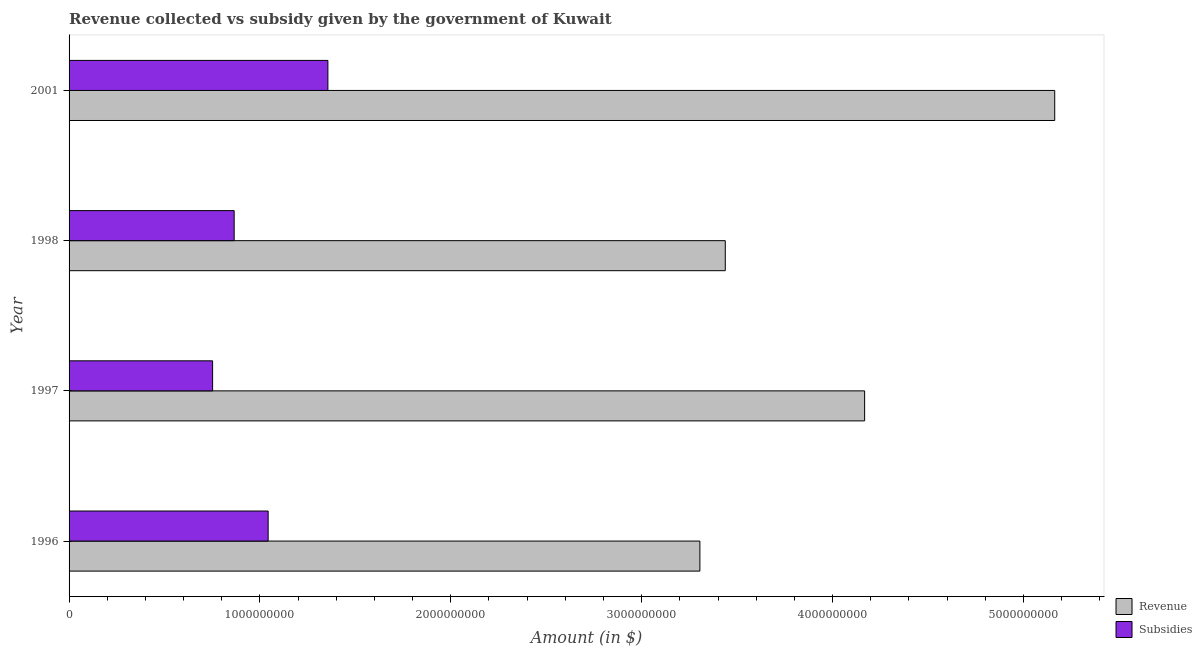How many different coloured bars are there?
Provide a succinct answer. 2. Are the number of bars on each tick of the Y-axis equal?
Give a very brief answer. Yes. How many bars are there on the 4th tick from the top?
Ensure brevity in your answer.  2. What is the label of the 2nd group of bars from the top?
Offer a very short reply. 1998. In how many cases, is the number of bars for a given year not equal to the number of legend labels?
Your response must be concise. 0. What is the amount of revenue collected in 1998?
Give a very brief answer. 3.44e+09. Across all years, what is the maximum amount of revenue collected?
Your response must be concise. 5.16e+09. Across all years, what is the minimum amount of subsidies given?
Provide a succinct answer. 7.52e+08. In which year was the amount of subsidies given minimum?
Keep it short and to the point. 1997. What is the total amount of subsidies given in the graph?
Your response must be concise. 4.02e+09. What is the difference between the amount of revenue collected in 1996 and that in 1997?
Your answer should be very brief. -8.63e+08. What is the difference between the amount of subsidies given in 1997 and the amount of revenue collected in 1996?
Offer a very short reply. -2.55e+09. What is the average amount of revenue collected per year?
Keep it short and to the point. 4.02e+09. In the year 1998, what is the difference between the amount of subsidies given and amount of revenue collected?
Provide a short and direct response. -2.57e+09. In how many years, is the amount of revenue collected greater than 4800000000 $?
Your answer should be compact. 1. What is the ratio of the amount of subsidies given in 1998 to that in 2001?
Offer a terse response. 0.64. Is the amount of revenue collected in 1996 less than that in 2001?
Offer a very short reply. Yes. Is the difference between the amount of revenue collected in 1996 and 2001 greater than the difference between the amount of subsidies given in 1996 and 2001?
Give a very brief answer. No. What is the difference between the highest and the second highest amount of revenue collected?
Your answer should be very brief. 9.96e+08. What is the difference between the highest and the lowest amount of revenue collected?
Provide a short and direct response. 1.86e+09. In how many years, is the amount of revenue collected greater than the average amount of revenue collected taken over all years?
Provide a short and direct response. 2. What does the 1st bar from the top in 2001 represents?
Offer a terse response. Subsidies. What does the 1st bar from the bottom in 1998 represents?
Offer a terse response. Revenue. How many bars are there?
Give a very brief answer. 8. What is the difference between two consecutive major ticks on the X-axis?
Keep it short and to the point. 1.00e+09. Does the graph contain grids?
Your answer should be very brief. No. How many legend labels are there?
Your answer should be very brief. 2. How are the legend labels stacked?
Provide a succinct answer. Vertical. What is the title of the graph?
Your response must be concise. Revenue collected vs subsidy given by the government of Kuwait. What is the label or title of the X-axis?
Offer a terse response. Amount (in $). What is the Amount (in $) of Revenue in 1996?
Keep it short and to the point. 3.30e+09. What is the Amount (in $) in Subsidies in 1996?
Provide a succinct answer. 1.04e+09. What is the Amount (in $) of Revenue in 1997?
Offer a terse response. 4.17e+09. What is the Amount (in $) in Subsidies in 1997?
Provide a succinct answer. 7.52e+08. What is the Amount (in $) of Revenue in 1998?
Offer a very short reply. 3.44e+09. What is the Amount (in $) of Subsidies in 1998?
Your answer should be compact. 8.65e+08. What is the Amount (in $) of Revenue in 2001?
Give a very brief answer. 5.16e+09. What is the Amount (in $) in Subsidies in 2001?
Your answer should be very brief. 1.36e+09. Across all years, what is the maximum Amount (in $) in Revenue?
Offer a very short reply. 5.16e+09. Across all years, what is the maximum Amount (in $) of Subsidies?
Offer a very short reply. 1.36e+09. Across all years, what is the minimum Amount (in $) of Revenue?
Make the answer very short. 3.30e+09. Across all years, what is the minimum Amount (in $) of Subsidies?
Keep it short and to the point. 7.52e+08. What is the total Amount (in $) in Revenue in the graph?
Offer a terse response. 1.61e+1. What is the total Amount (in $) of Subsidies in the graph?
Your response must be concise. 4.02e+09. What is the difference between the Amount (in $) of Revenue in 1996 and that in 1997?
Provide a succinct answer. -8.63e+08. What is the difference between the Amount (in $) in Subsidies in 1996 and that in 1997?
Keep it short and to the point. 2.91e+08. What is the difference between the Amount (in $) of Revenue in 1996 and that in 1998?
Ensure brevity in your answer.  -1.33e+08. What is the difference between the Amount (in $) of Subsidies in 1996 and that in 1998?
Your answer should be compact. 1.78e+08. What is the difference between the Amount (in $) in Revenue in 1996 and that in 2001?
Give a very brief answer. -1.86e+09. What is the difference between the Amount (in $) of Subsidies in 1996 and that in 2001?
Make the answer very short. -3.13e+08. What is the difference between the Amount (in $) in Revenue in 1997 and that in 1998?
Keep it short and to the point. 7.30e+08. What is the difference between the Amount (in $) of Subsidies in 1997 and that in 1998?
Provide a succinct answer. -1.13e+08. What is the difference between the Amount (in $) in Revenue in 1997 and that in 2001?
Offer a terse response. -9.96e+08. What is the difference between the Amount (in $) of Subsidies in 1997 and that in 2001?
Provide a succinct answer. -6.04e+08. What is the difference between the Amount (in $) of Revenue in 1998 and that in 2001?
Make the answer very short. -1.73e+09. What is the difference between the Amount (in $) of Subsidies in 1998 and that in 2001?
Keep it short and to the point. -4.91e+08. What is the difference between the Amount (in $) in Revenue in 1996 and the Amount (in $) in Subsidies in 1997?
Your answer should be very brief. 2.55e+09. What is the difference between the Amount (in $) in Revenue in 1996 and the Amount (in $) in Subsidies in 1998?
Your answer should be compact. 2.44e+09. What is the difference between the Amount (in $) of Revenue in 1996 and the Amount (in $) of Subsidies in 2001?
Your answer should be very brief. 1.95e+09. What is the difference between the Amount (in $) of Revenue in 1997 and the Amount (in $) of Subsidies in 1998?
Keep it short and to the point. 3.30e+09. What is the difference between the Amount (in $) of Revenue in 1997 and the Amount (in $) of Subsidies in 2001?
Your answer should be compact. 2.81e+09. What is the difference between the Amount (in $) in Revenue in 1998 and the Amount (in $) in Subsidies in 2001?
Your answer should be very brief. 2.08e+09. What is the average Amount (in $) in Revenue per year?
Your answer should be compact. 4.02e+09. What is the average Amount (in $) of Subsidies per year?
Your answer should be compact. 1.00e+09. In the year 1996, what is the difference between the Amount (in $) of Revenue and Amount (in $) of Subsidies?
Your answer should be very brief. 2.26e+09. In the year 1997, what is the difference between the Amount (in $) in Revenue and Amount (in $) in Subsidies?
Keep it short and to the point. 3.42e+09. In the year 1998, what is the difference between the Amount (in $) in Revenue and Amount (in $) in Subsidies?
Make the answer very short. 2.57e+09. In the year 2001, what is the difference between the Amount (in $) in Revenue and Amount (in $) in Subsidies?
Provide a short and direct response. 3.81e+09. What is the ratio of the Amount (in $) in Revenue in 1996 to that in 1997?
Keep it short and to the point. 0.79. What is the ratio of the Amount (in $) in Subsidies in 1996 to that in 1997?
Keep it short and to the point. 1.39. What is the ratio of the Amount (in $) of Revenue in 1996 to that in 1998?
Make the answer very short. 0.96. What is the ratio of the Amount (in $) of Subsidies in 1996 to that in 1998?
Your answer should be very brief. 1.21. What is the ratio of the Amount (in $) of Revenue in 1996 to that in 2001?
Offer a very short reply. 0.64. What is the ratio of the Amount (in $) of Subsidies in 1996 to that in 2001?
Offer a very short reply. 0.77. What is the ratio of the Amount (in $) in Revenue in 1997 to that in 1998?
Provide a short and direct response. 1.21. What is the ratio of the Amount (in $) in Subsidies in 1997 to that in 1998?
Ensure brevity in your answer.  0.87. What is the ratio of the Amount (in $) in Revenue in 1997 to that in 2001?
Offer a terse response. 0.81. What is the ratio of the Amount (in $) of Subsidies in 1997 to that in 2001?
Keep it short and to the point. 0.55. What is the ratio of the Amount (in $) of Revenue in 1998 to that in 2001?
Your response must be concise. 0.67. What is the ratio of the Amount (in $) in Subsidies in 1998 to that in 2001?
Offer a terse response. 0.64. What is the difference between the highest and the second highest Amount (in $) of Revenue?
Your answer should be compact. 9.96e+08. What is the difference between the highest and the second highest Amount (in $) in Subsidies?
Your response must be concise. 3.13e+08. What is the difference between the highest and the lowest Amount (in $) of Revenue?
Ensure brevity in your answer.  1.86e+09. What is the difference between the highest and the lowest Amount (in $) in Subsidies?
Offer a very short reply. 6.04e+08. 